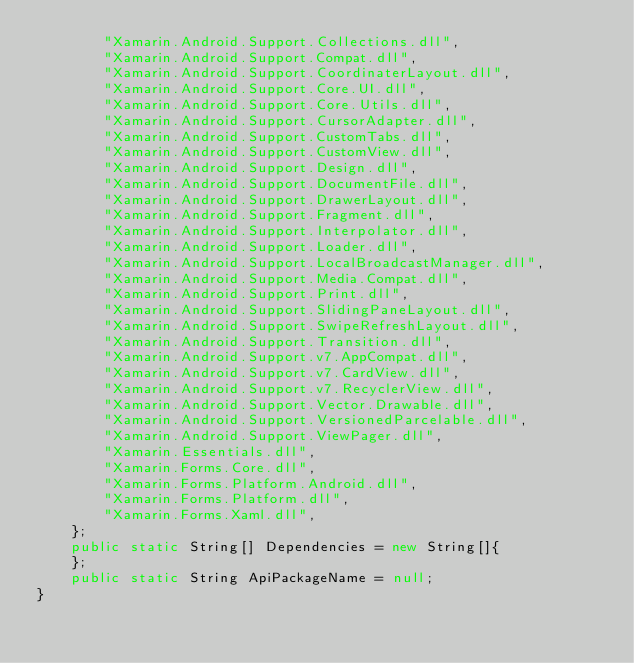<code> <loc_0><loc_0><loc_500><loc_500><_Java_>		"Xamarin.Android.Support.Collections.dll",
		"Xamarin.Android.Support.Compat.dll",
		"Xamarin.Android.Support.CoordinaterLayout.dll",
		"Xamarin.Android.Support.Core.UI.dll",
		"Xamarin.Android.Support.Core.Utils.dll",
		"Xamarin.Android.Support.CursorAdapter.dll",
		"Xamarin.Android.Support.CustomTabs.dll",
		"Xamarin.Android.Support.CustomView.dll",
		"Xamarin.Android.Support.Design.dll",
		"Xamarin.Android.Support.DocumentFile.dll",
		"Xamarin.Android.Support.DrawerLayout.dll",
		"Xamarin.Android.Support.Fragment.dll",
		"Xamarin.Android.Support.Interpolator.dll",
		"Xamarin.Android.Support.Loader.dll",
		"Xamarin.Android.Support.LocalBroadcastManager.dll",
		"Xamarin.Android.Support.Media.Compat.dll",
		"Xamarin.Android.Support.Print.dll",
		"Xamarin.Android.Support.SlidingPaneLayout.dll",
		"Xamarin.Android.Support.SwipeRefreshLayout.dll",
		"Xamarin.Android.Support.Transition.dll",
		"Xamarin.Android.Support.v7.AppCompat.dll",
		"Xamarin.Android.Support.v7.CardView.dll",
		"Xamarin.Android.Support.v7.RecyclerView.dll",
		"Xamarin.Android.Support.Vector.Drawable.dll",
		"Xamarin.Android.Support.VersionedParcelable.dll",
		"Xamarin.Android.Support.ViewPager.dll",
		"Xamarin.Essentials.dll",
		"Xamarin.Forms.Core.dll",
		"Xamarin.Forms.Platform.Android.dll",
		"Xamarin.Forms.Platform.dll",
		"Xamarin.Forms.Xaml.dll",
	};
	public static String[] Dependencies = new String[]{
	};
	public static String ApiPackageName = null;
}
</code> 